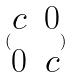<formula> <loc_0><loc_0><loc_500><loc_500>( \begin{matrix} c & 0 \\ 0 & c \end{matrix} )</formula> 